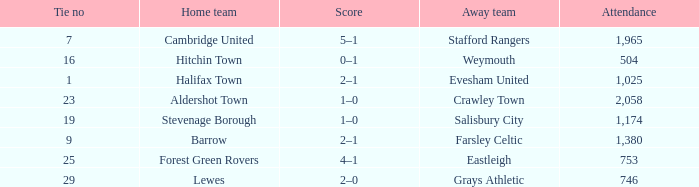What is the highest attendance for games with stevenage borough at home? 1174.0. 